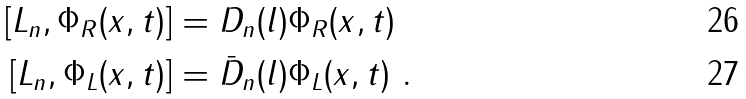<formula> <loc_0><loc_0><loc_500><loc_500>[ L _ { n } , \Phi _ { R } ( x , t ) ] & = D _ { n } ( l ) \Phi _ { R } ( x , t ) \\ [ L _ { n } , \Phi _ { L } ( x , t ) ] & = \bar { D } _ { n } ( l ) \Phi _ { L } ( x , t ) \ .</formula> 